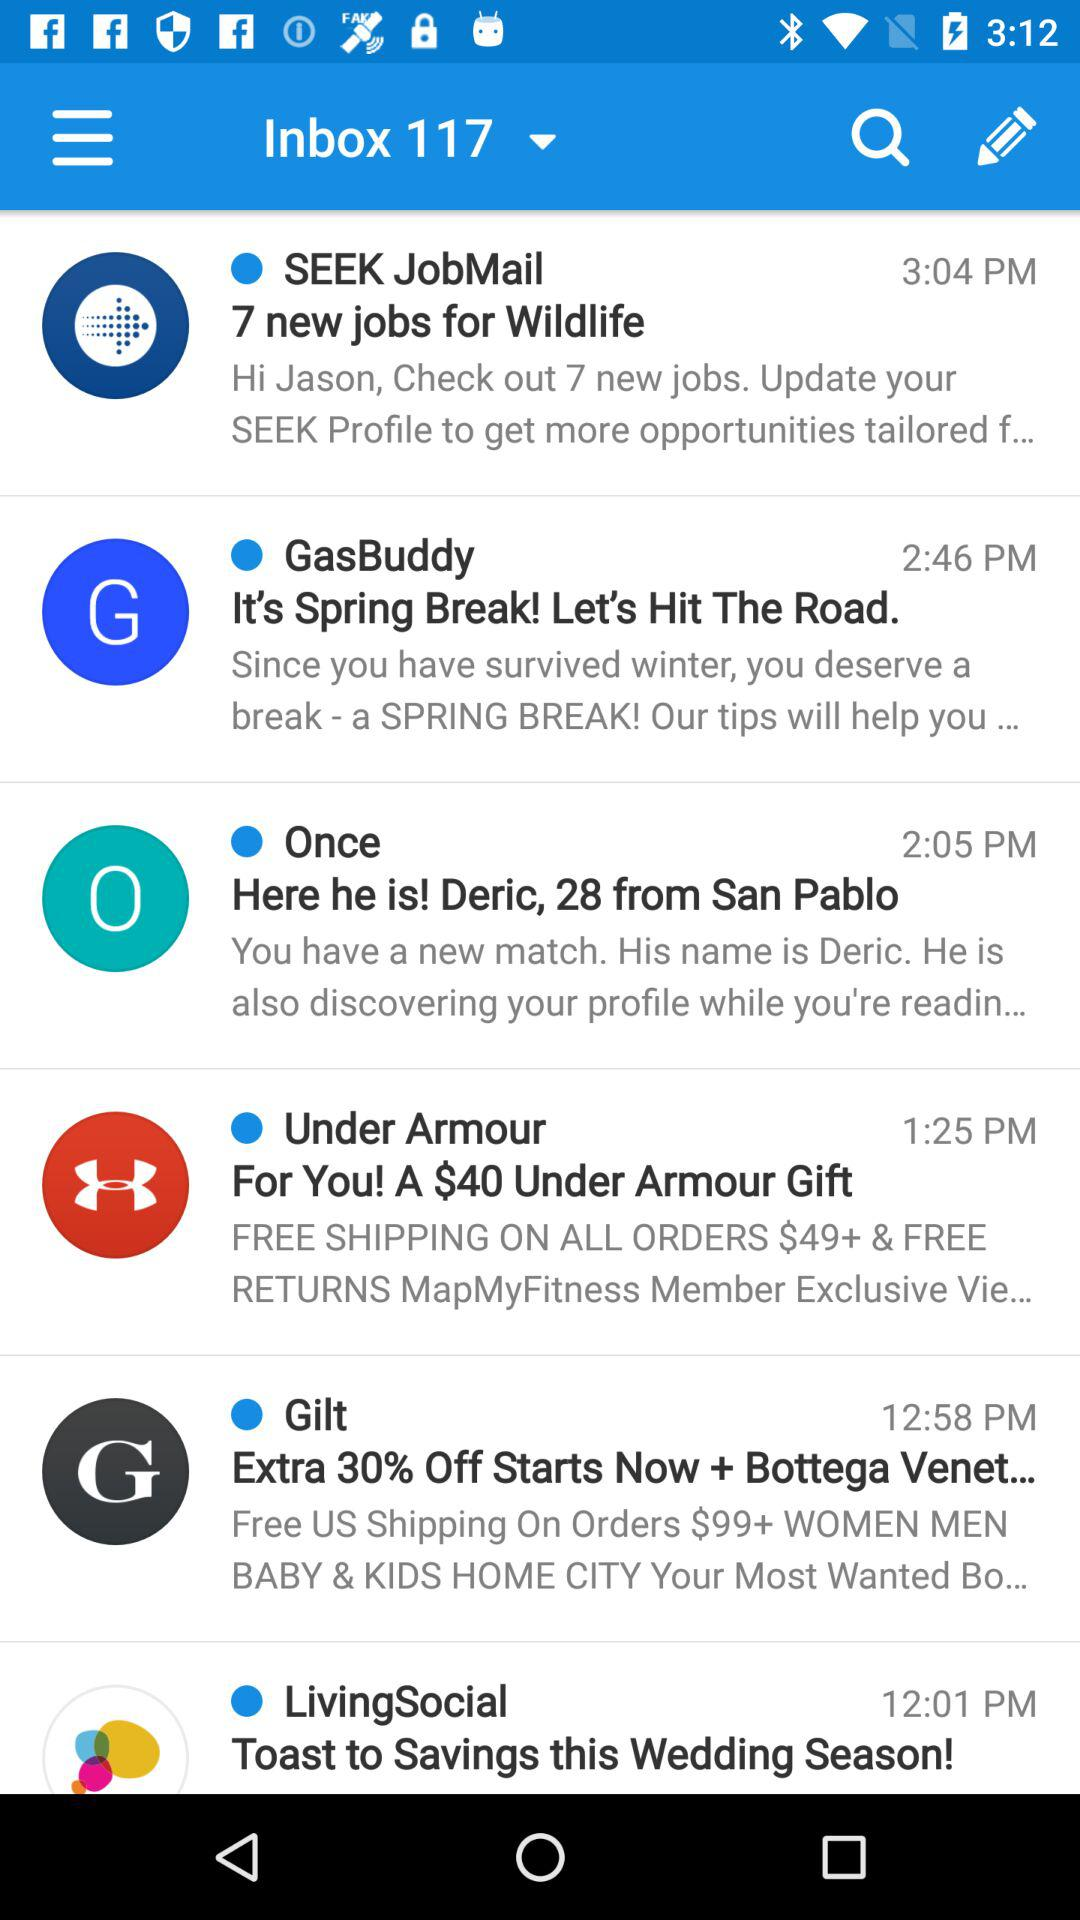What is the time of the email from "GasBuddy"? The time of the email is 2:46 p.m. 